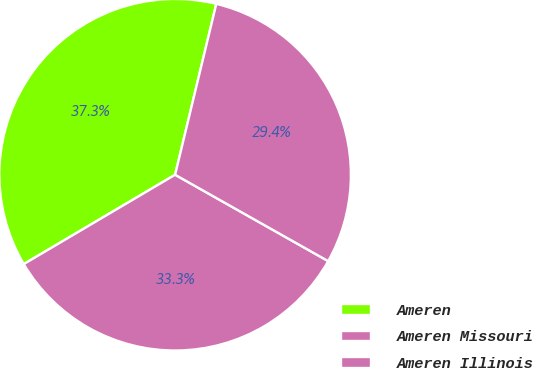<chart> <loc_0><loc_0><loc_500><loc_500><pie_chart><fcel>Ameren<fcel>Ameren Missouri<fcel>Ameren Illinois<nl><fcel>37.25%<fcel>33.33%<fcel>29.41%<nl></chart> 